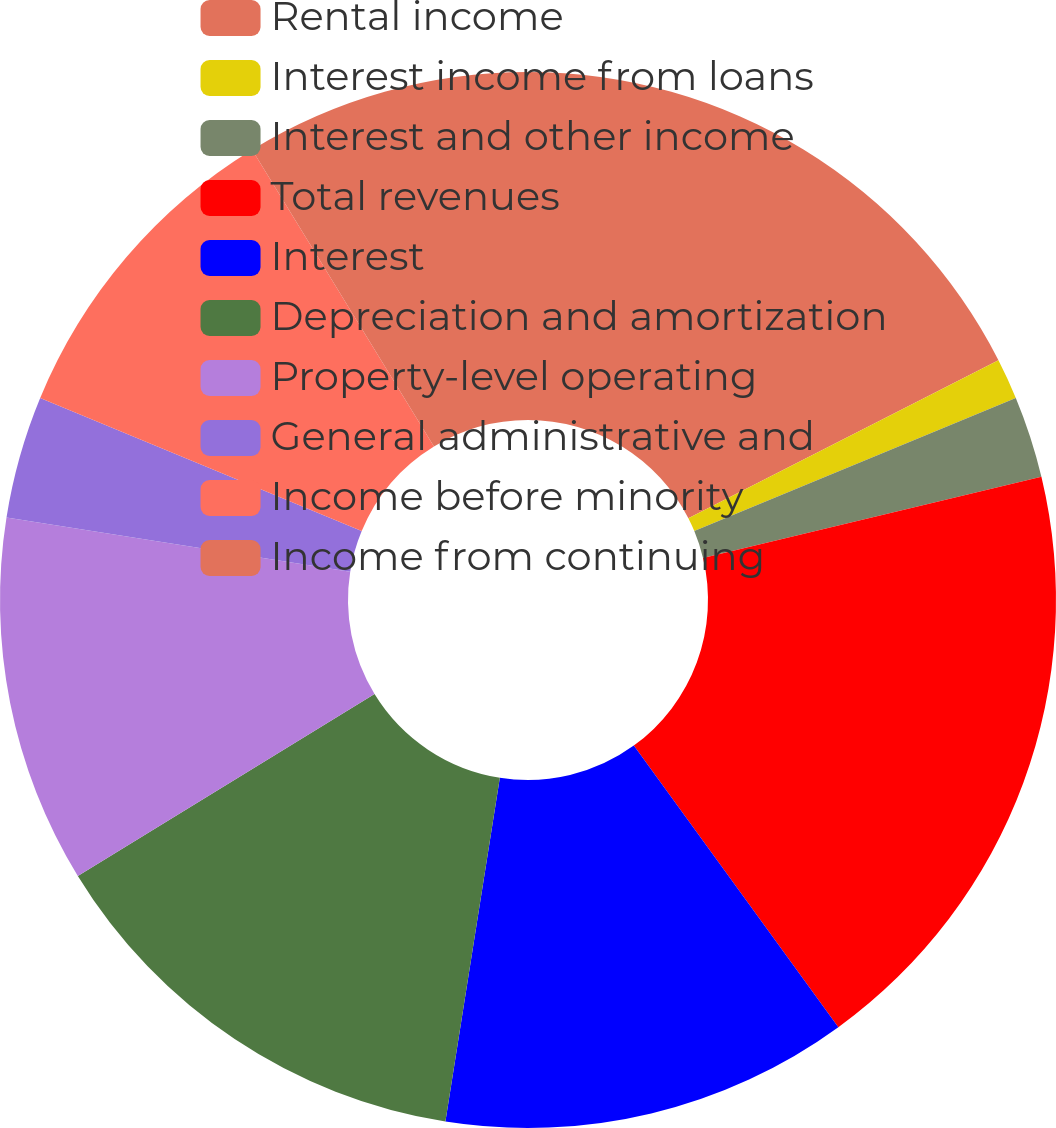<chart> <loc_0><loc_0><loc_500><loc_500><pie_chart><fcel>Rental income<fcel>Interest income from loans<fcel>Interest and other income<fcel>Total revenues<fcel>Interest<fcel>Depreciation and amortization<fcel>Property-level operating<fcel>General administrative and<fcel>Income before minority<fcel>Income from continuing<nl><fcel>17.5%<fcel>1.25%<fcel>2.5%<fcel>18.75%<fcel>12.5%<fcel>13.75%<fcel>11.25%<fcel>3.75%<fcel>10.0%<fcel>8.75%<nl></chart> 